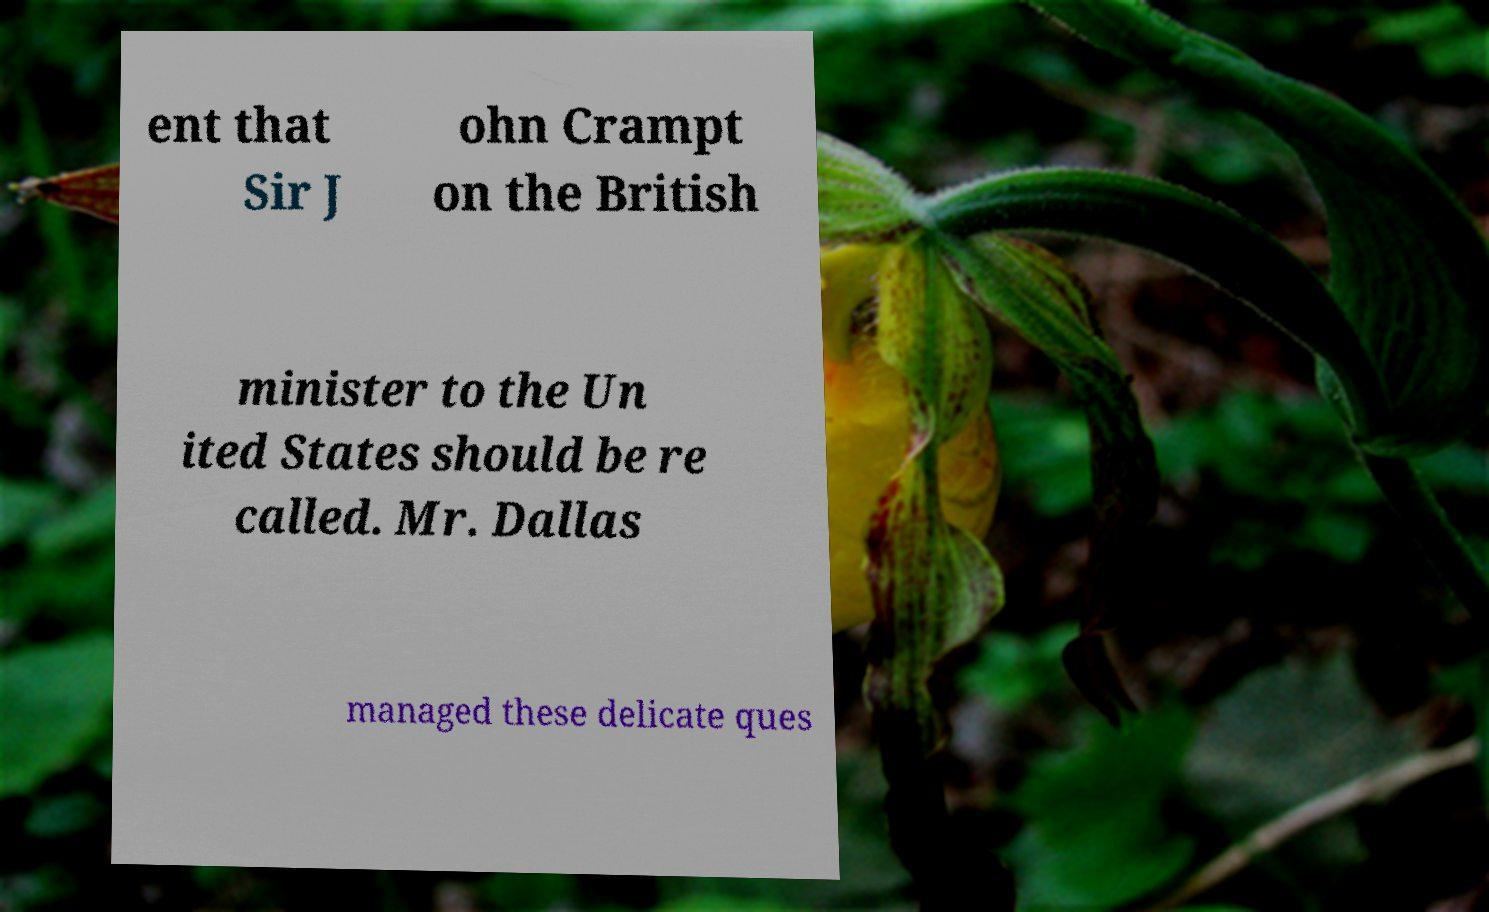Please read and relay the text visible in this image. What does it say? ent that Sir J ohn Crampt on the British minister to the Un ited States should be re called. Mr. Dallas managed these delicate ques 